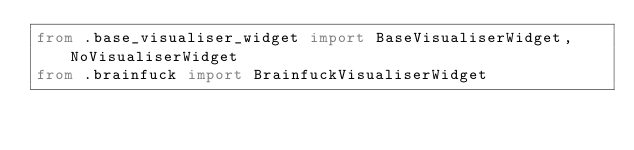<code> <loc_0><loc_0><loc_500><loc_500><_Python_>from .base_visualiser_widget import BaseVisualiserWidget, NoVisualiserWidget
from .brainfuck import BrainfuckVisualiserWidget
</code> 